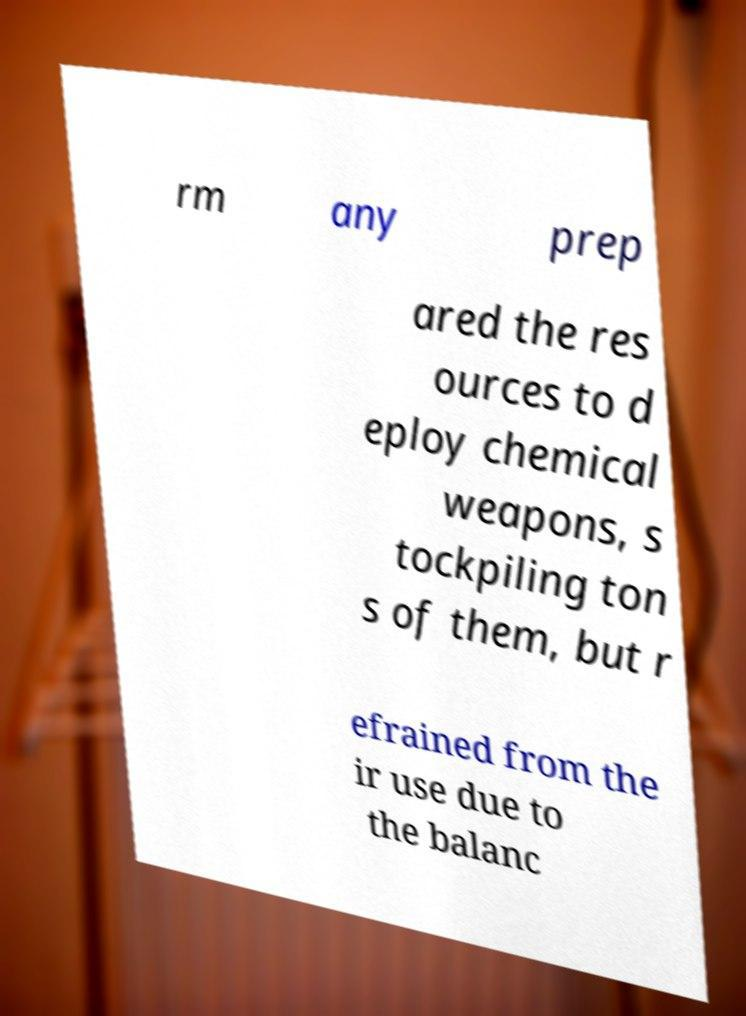Could you extract and type out the text from this image? rm any prep ared the res ources to d eploy chemical weapons, s tockpiling ton s of them, but r efrained from the ir use due to the balanc 